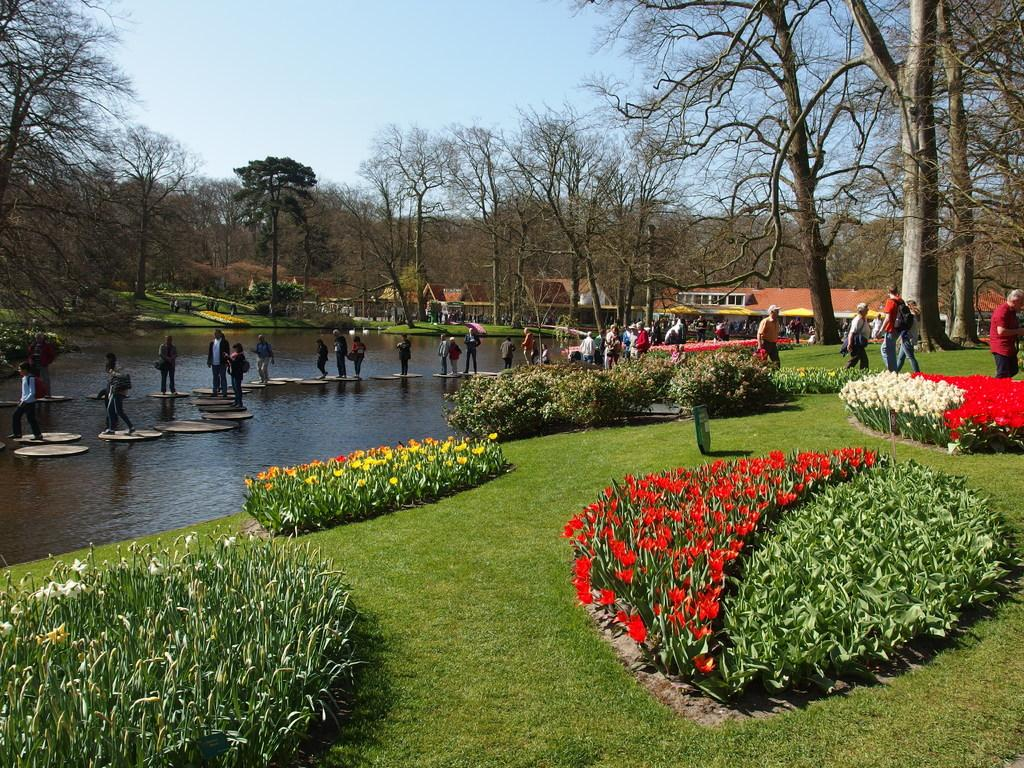What type of vegetation can be seen in the image? There are flowers, plants, and grass visible in the image. Is there any water present in the image? Yes, there is water visible in the image. Are there any people in the image? Yes, there are people in the image. What can be seen in the background of the image? There are trees and the sky visible in the background of the image. What type of coal is being used to fuel the fire in the image? There is no fire or coal present in the image; it features flowers, plants, grass, water, people, trees, and the sky. What word is being spelled out by the people in the image? There is no word being spelled out by the people in the image. 